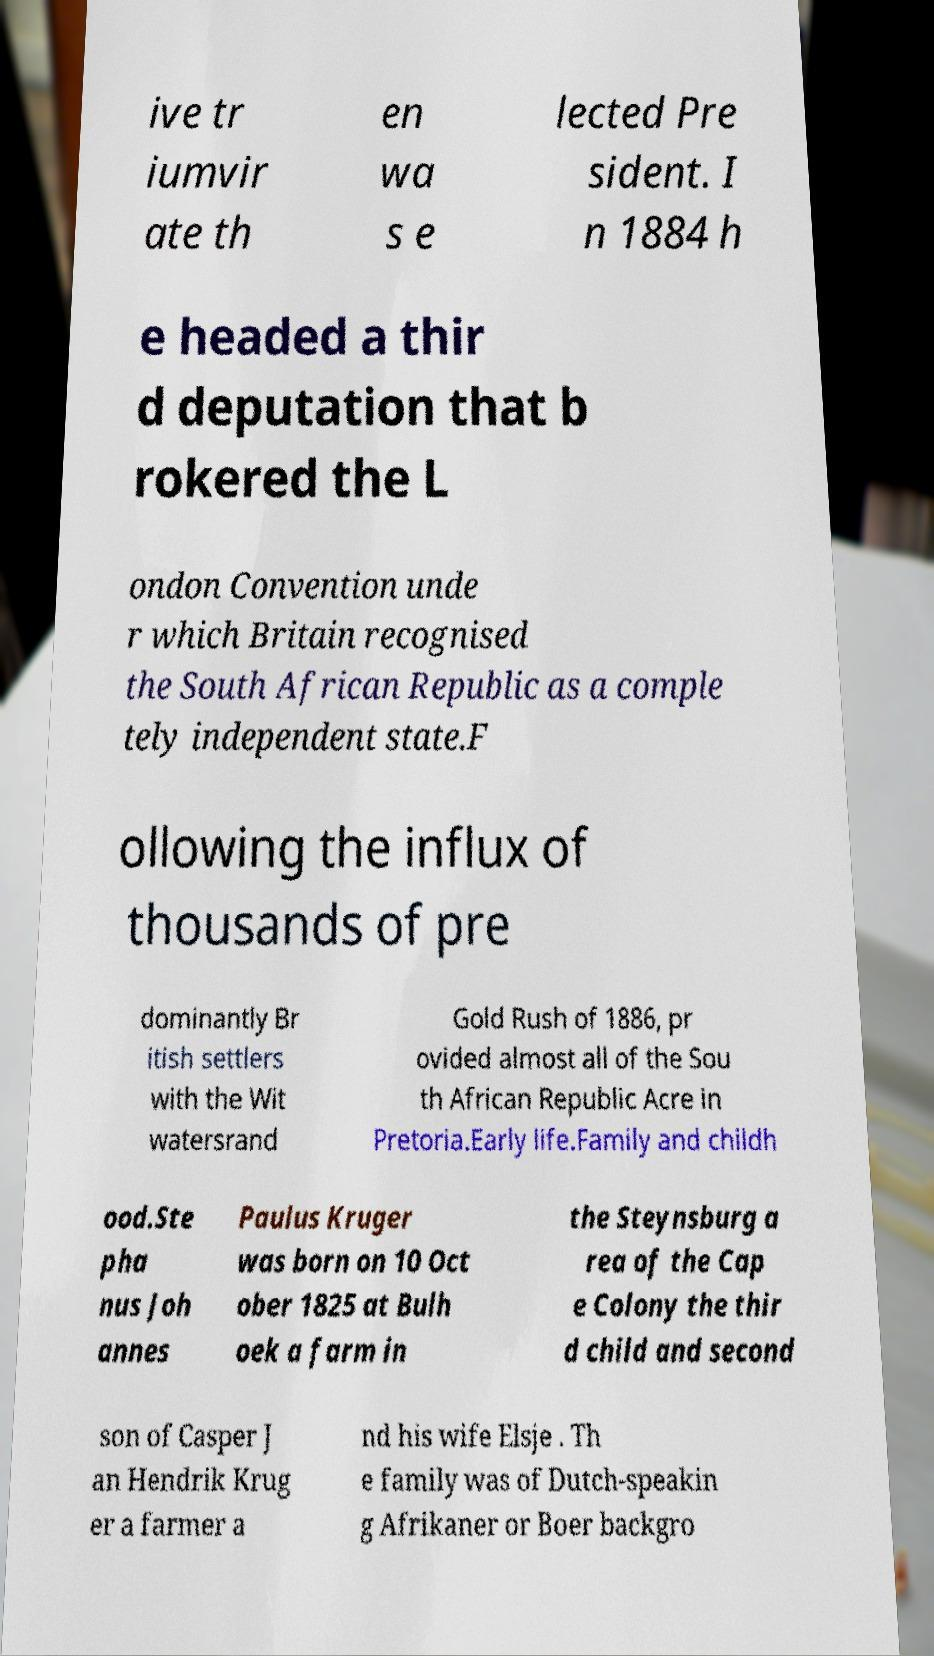Can you accurately transcribe the text from the provided image for me? ive tr iumvir ate th en wa s e lected Pre sident. I n 1884 h e headed a thir d deputation that b rokered the L ondon Convention unde r which Britain recognised the South African Republic as a comple tely independent state.F ollowing the influx of thousands of pre dominantly Br itish settlers with the Wit watersrand Gold Rush of 1886, pr ovided almost all of the Sou th African Republic Acre in Pretoria.Early life.Family and childh ood.Ste pha nus Joh annes Paulus Kruger was born on 10 Oct ober 1825 at Bulh oek a farm in the Steynsburg a rea of the Cap e Colony the thir d child and second son of Casper J an Hendrik Krug er a farmer a nd his wife Elsje . Th e family was of Dutch-speakin g Afrikaner or Boer backgro 